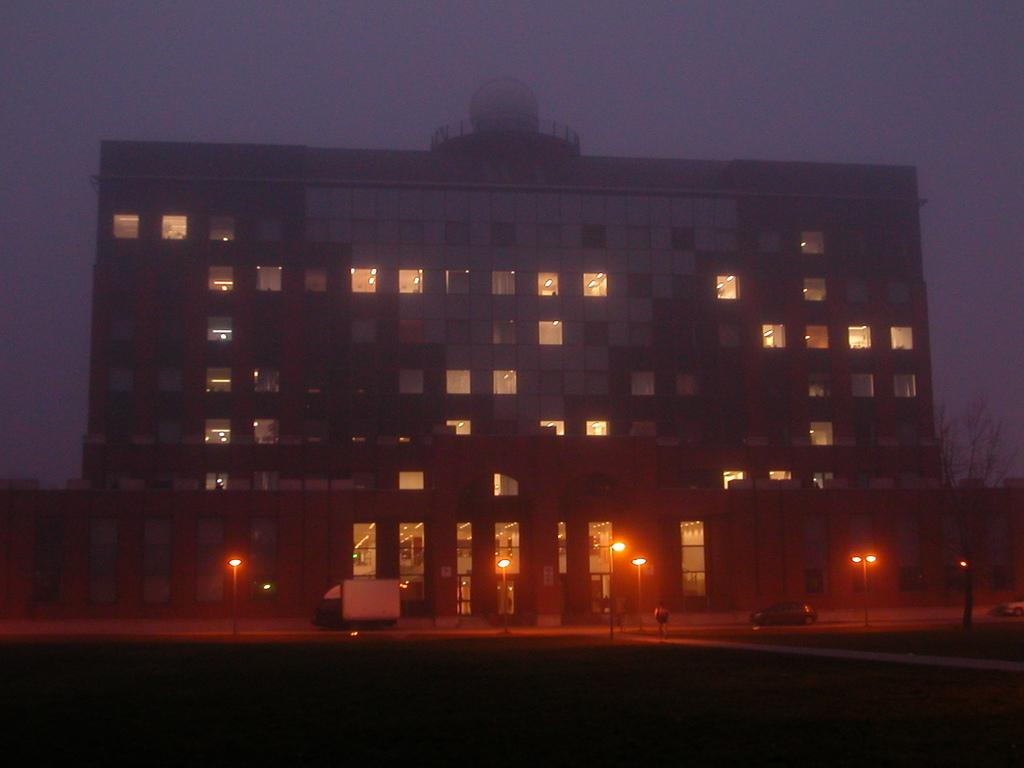What type of structure is visible in the image? There is a building in the image. What is located in front of the building? There is a road in front of the building. What can be seen on the road? There are vehicles on the road. What else is present on the road besides vehicles? There are light poles on the road. What type of cap is the building wearing in the image? There is no cap present in the image; it is a building with a roof. What scientific theory is being demonstrated in the image? There is no scientific theory being demonstrated in the image; it is a simple scene featuring a building, road, vehicles, and light poles. 